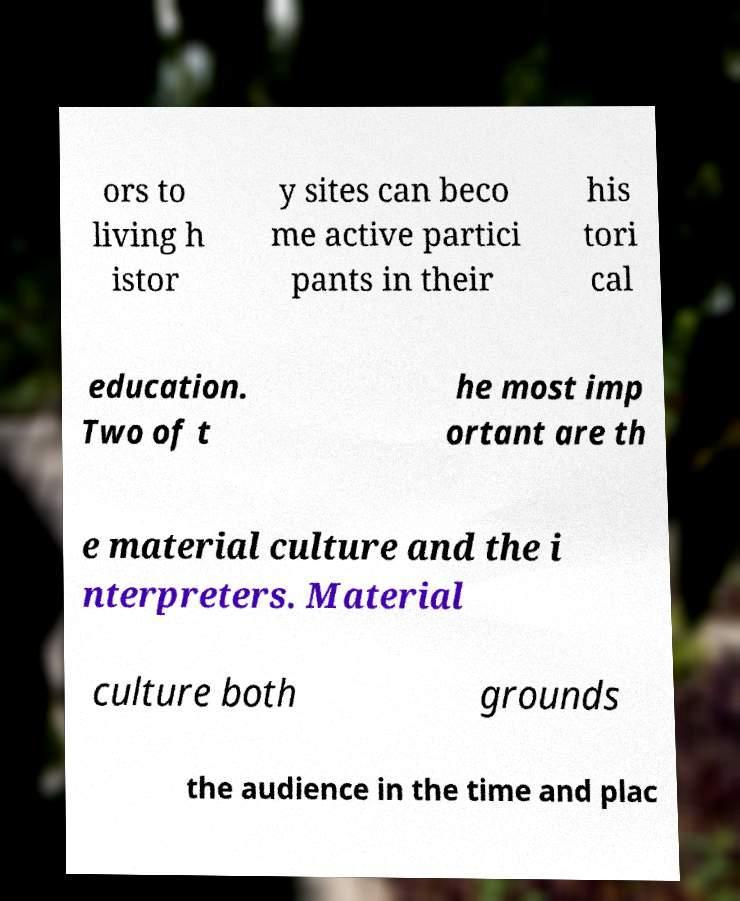Can you read and provide the text displayed in the image?This photo seems to have some interesting text. Can you extract and type it out for me? ors to living h istor y sites can beco me active partici pants in their his tori cal education. Two of t he most imp ortant are th e material culture and the i nterpreters. Material culture both grounds the audience in the time and plac 